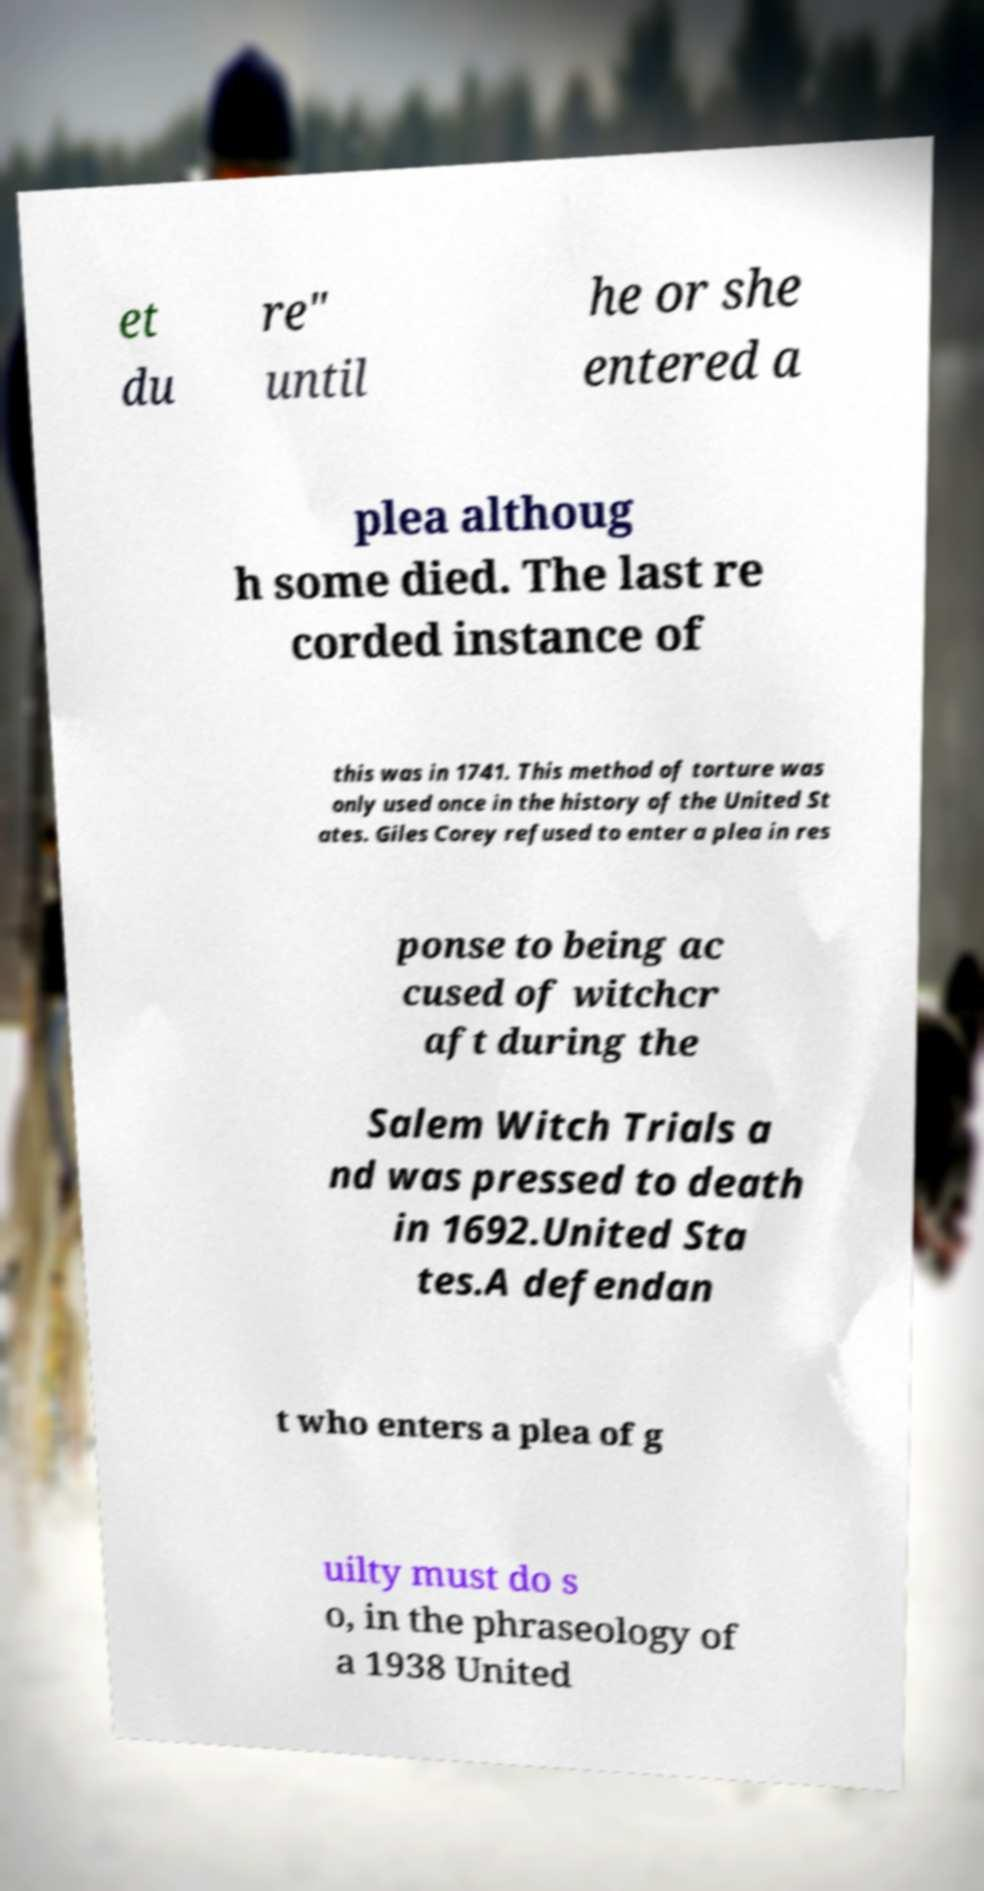Please identify and transcribe the text found in this image. et du re" until he or she entered a plea althoug h some died. The last re corded instance of this was in 1741. This method of torture was only used once in the history of the United St ates. Giles Corey refused to enter a plea in res ponse to being ac cused of witchcr aft during the Salem Witch Trials a nd was pressed to death in 1692.United Sta tes.A defendan t who enters a plea of g uilty must do s o, in the phraseology of a 1938 United 